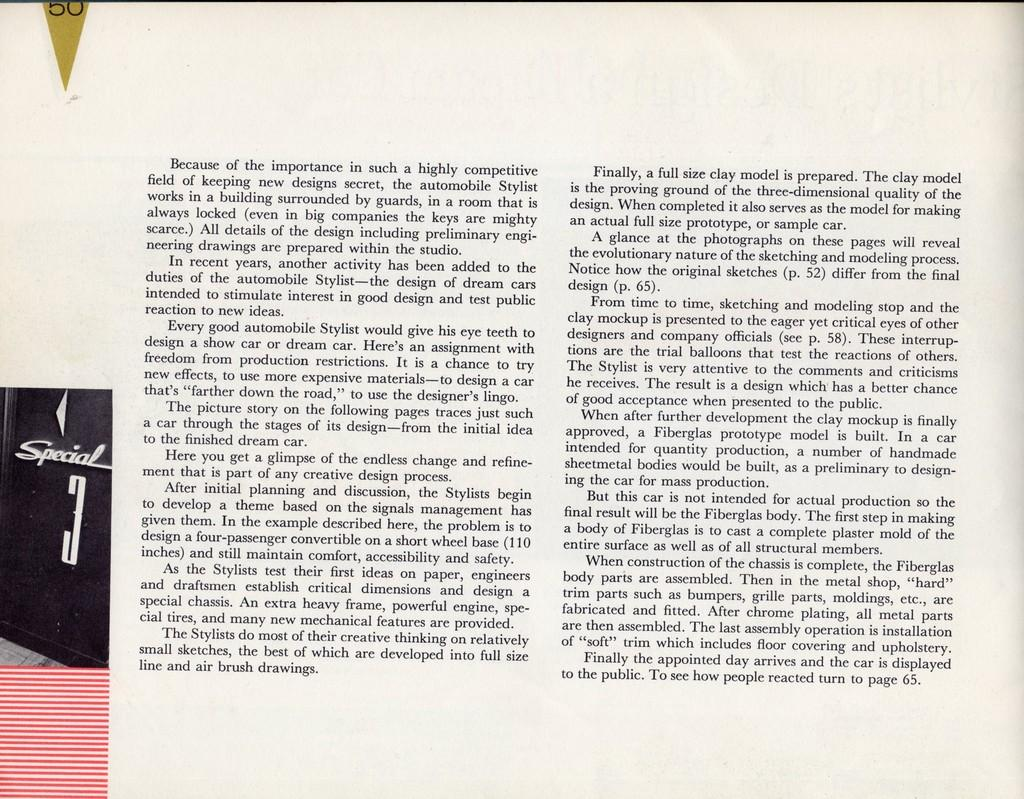<image>
Summarize the visual content of the image. A book is open to page 50 which features two columns of text and a box saying Special 3 in the corner. 